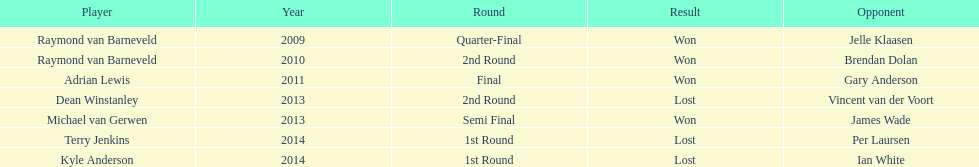Who was the winner of the initial world darts championship? Raymond van Barneveld. 